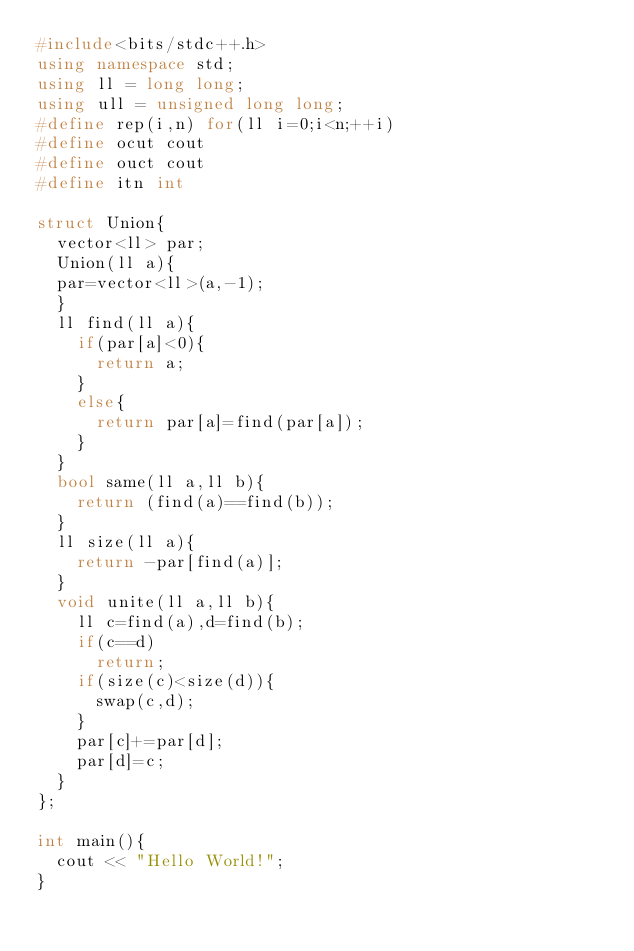Convert code to text. <code><loc_0><loc_0><loc_500><loc_500><_C++_>#include<bits/stdc++.h>
using namespace std;
using ll = long long;
using ull = unsigned long long;
#define rep(i,n) for(ll i=0;i<n;++i)
#define ocut cout
#define ouct cout
#define itn int

struct Union{
  vector<ll> par;
  Union(ll a){
  par=vector<ll>(a,-1);
  }
  ll find(ll a){
    if(par[a]<0){
      return a;
    }
    else{
      return par[a]=find(par[a]);
    }
  }
  bool same(ll a,ll b){
    return (find(a)==find(b));
  }
  ll size(ll a){
    return -par[find(a)];
  }
  void unite(ll a,ll b){
    ll c=find(a),d=find(b);
    if(c==d)
      return;
    if(size(c)<size(d)){
      swap(c,d);
    }
    par[c]+=par[d];
    par[d]=c;
  }
};

int main(){
  cout << "Hello World!";
}
</code> 